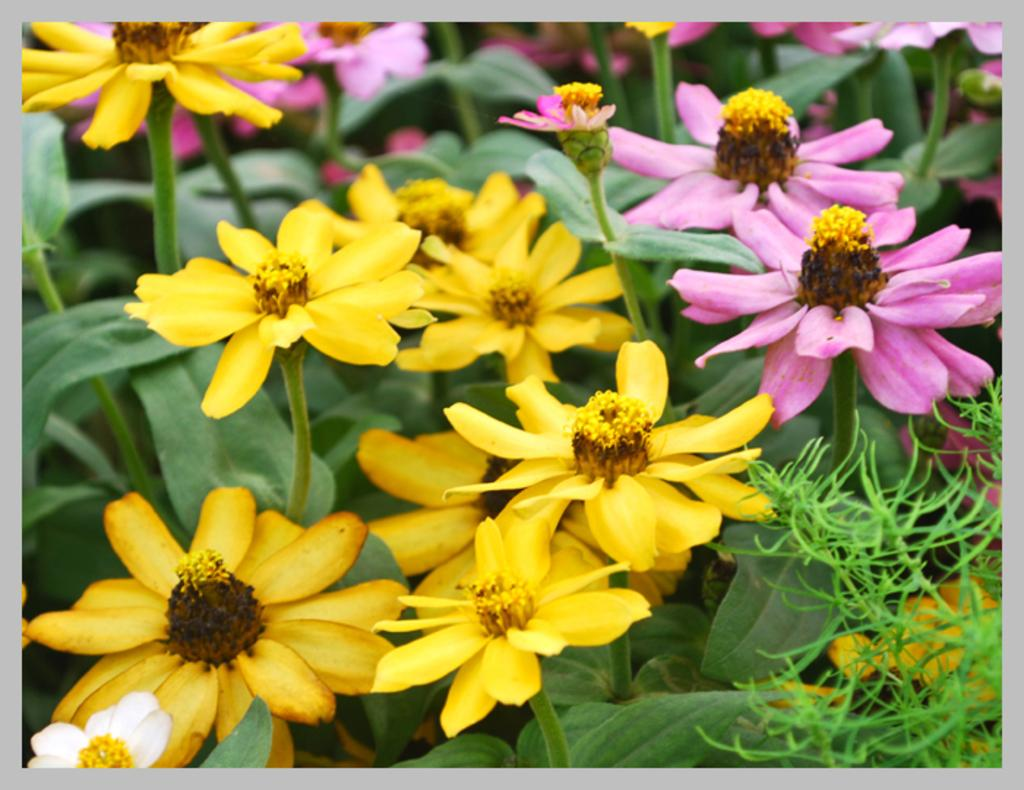What types of plants are present in the image? The image contains plants with different colored flowers. Can you describe the flowers on the plants? The flowers are present in different colors. What type of paper is used to create the country's flag in the image? There is no country or flag present in the image; it features plants with different colored flowers. 